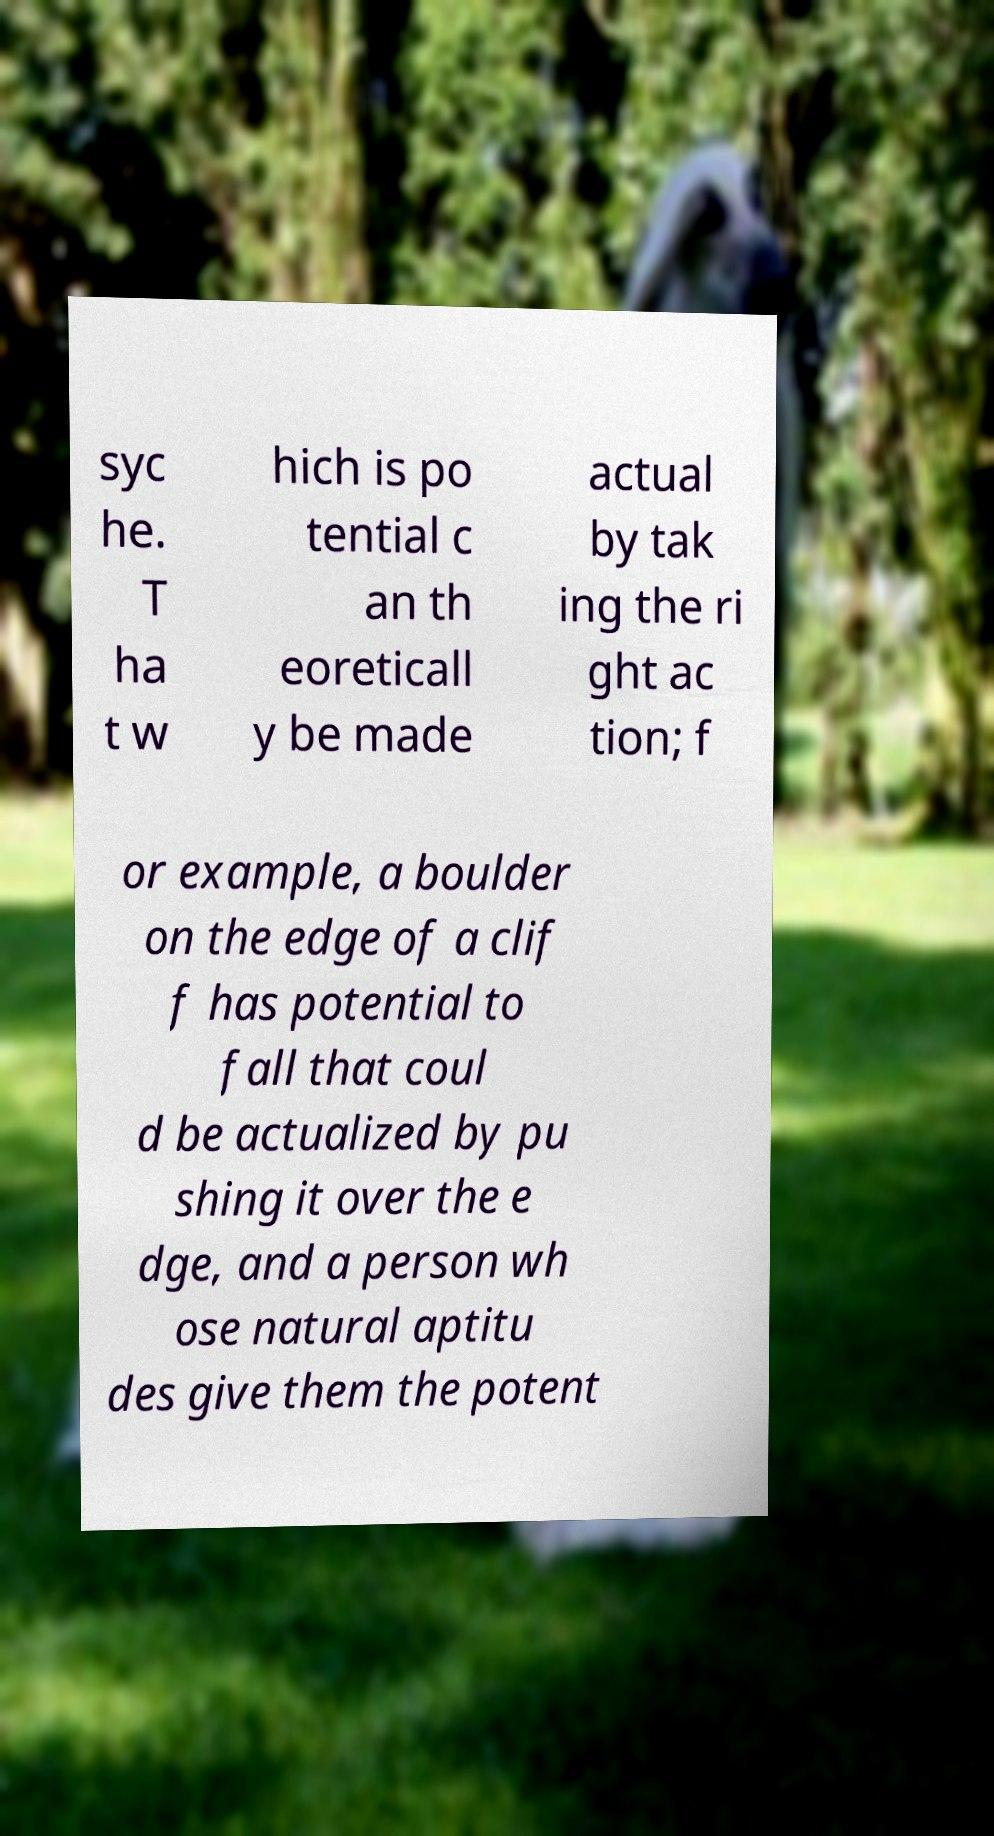What messages or text are displayed in this image? I need them in a readable, typed format. syc he. T ha t w hich is po tential c an th eoreticall y be made actual by tak ing the ri ght ac tion; f or example, a boulder on the edge of a clif f has potential to fall that coul d be actualized by pu shing it over the e dge, and a person wh ose natural aptitu des give them the potent 